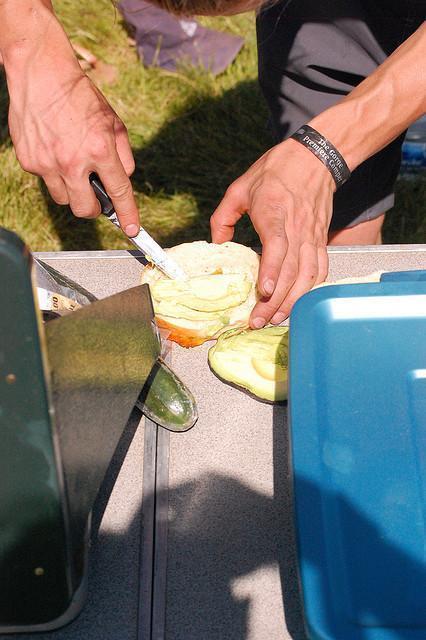At what type event is the man preparing food?
Pick the right solution, then justify: 'Answer: answer
Rationale: rationale.'
Options: Fancy brunch, bris, picnic, baby shower. Answer: picnic.
Rationale: He is outdoors as can be seen from the shadows and sunlight from above, and appears to be at a makeshift table and kitchen. 